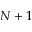<formula> <loc_0><loc_0><loc_500><loc_500>N + 1</formula> 